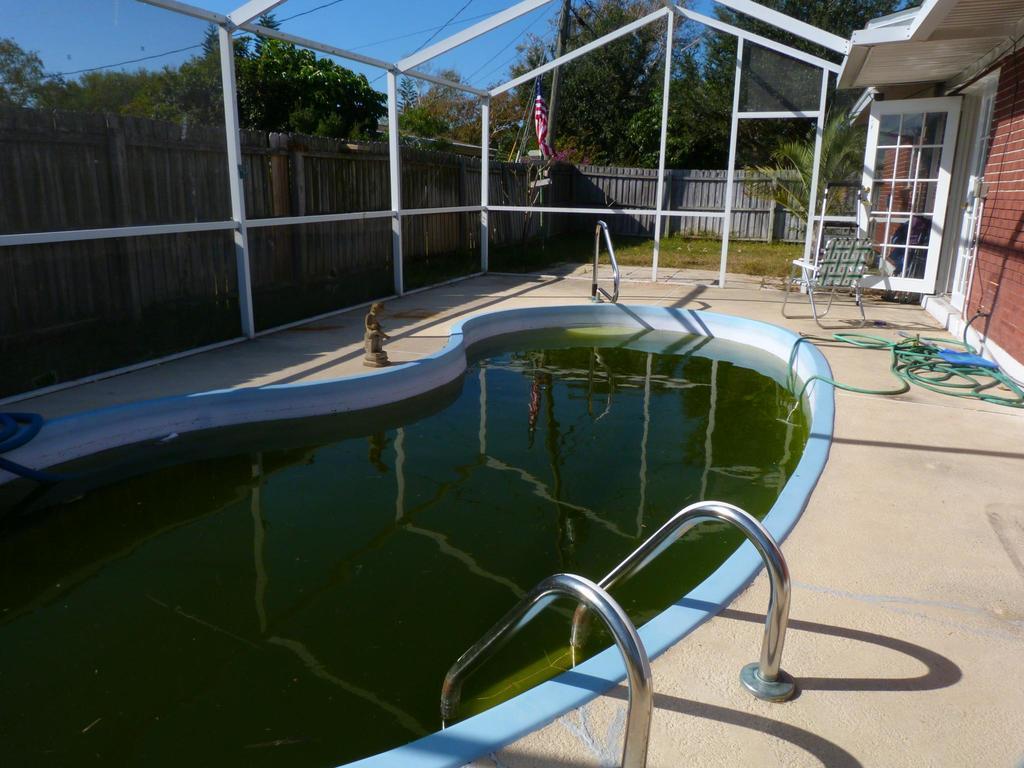How would you summarize this image in a sentence or two? In this picture we can see swimming pool at the bottom, on the right side there is a house, in the background there are some trees, we can see wooden fencing, a flag and some metal rods in the middle, there is the sky at the top of the picture. 